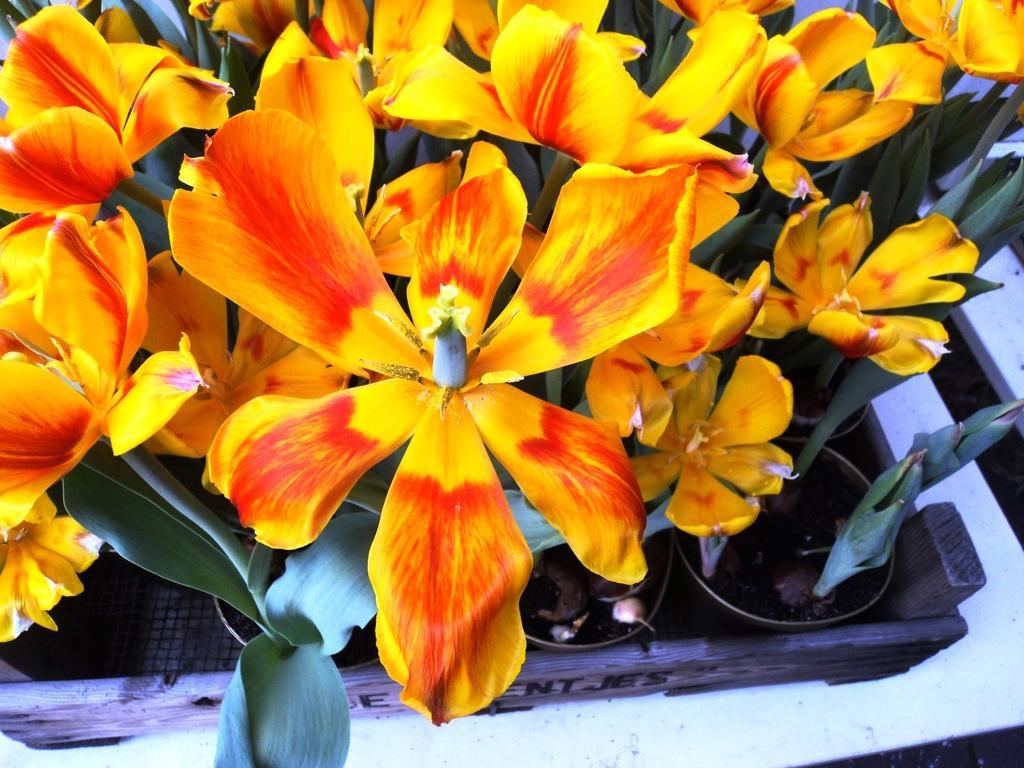Can you describe this image briefly? This image is a top view of a potted plants with flowers. I can see a wooden basket holding the potted plants. 